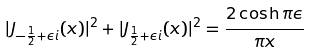Convert formula to latex. <formula><loc_0><loc_0><loc_500><loc_500>| J _ { - \frac { 1 } { 2 } + \epsilon i } ( x ) | ^ { 2 } + | J _ { \frac { 1 } { 2 } + \epsilon i } ( x ) | ^ { 2 } = \frac { 2 \cosh \pi \epsilon } { \pi x }</formula> 